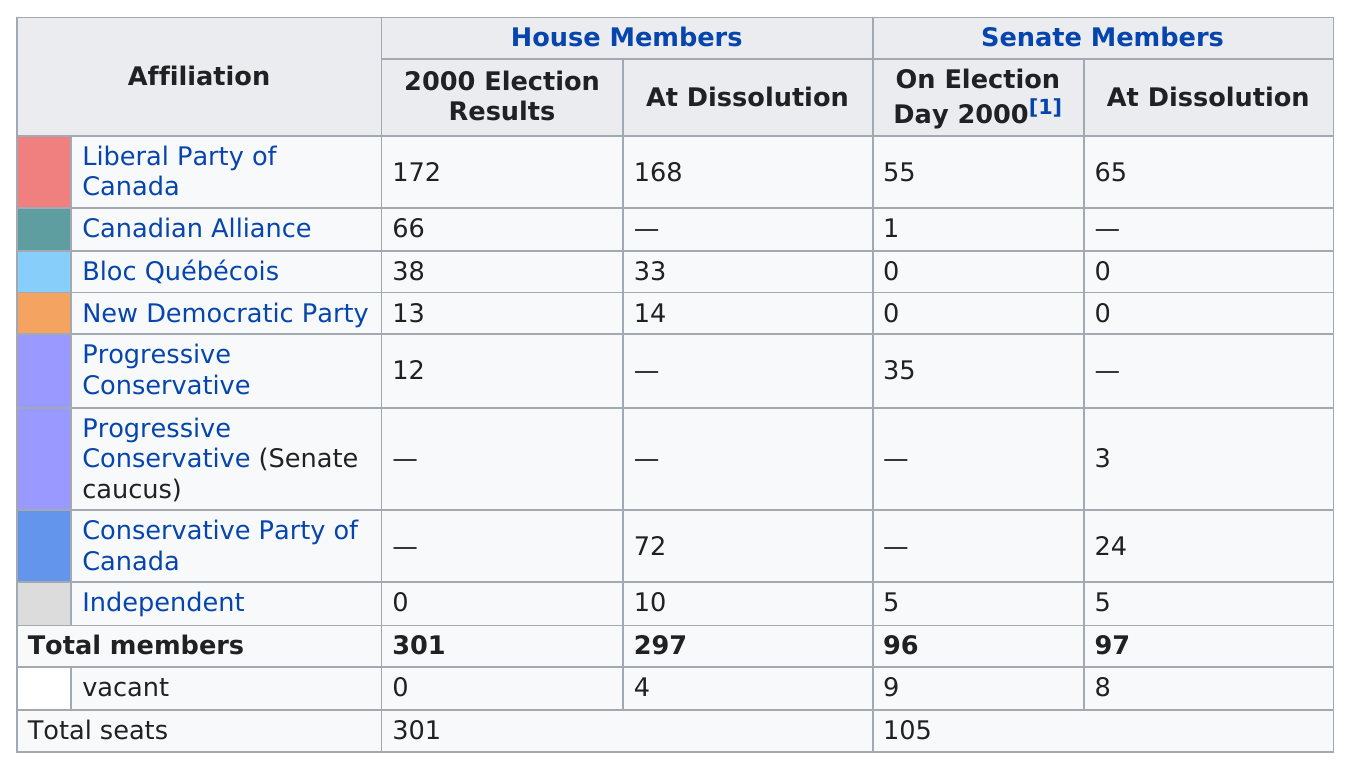Give some essential details in this illustration. In 2000, the Liberal Party of Canada had the highest number of members in the House of Commons. After the dissolution of the 37th Parliament of Canada, the New Democratic Party had one additional member of the House of Commons. After the dissolution of the 37th Parliament of Canada, the Liberal Party of Canada had fewer members in the Senate than before. The Liberal Party of Canada has the most members in the House of Commons. 